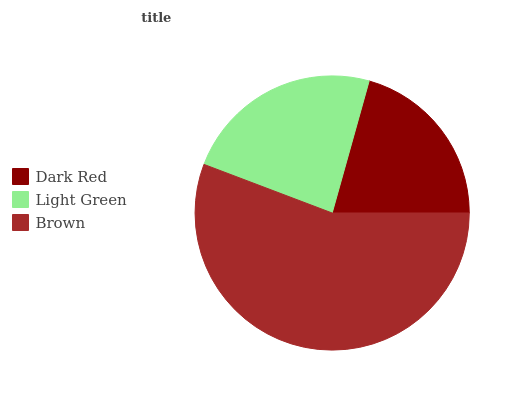Is Dark Red the minimum?
Answer yes or no. Yes. Is Brown the maximum?
Answer yes or no. Yes. Is Light Green the minimum?
Answer yes or no. No. Is Light Green the maximum?
Answer yes or no. No. Is Light Green greater than Dark Red?
Answer yes or no. Yes. Is Dark Red less than Light Green?
Answer yes or no. Yes. Is Dark Red greater than Light Green?
Answer yes or no. No. Is Light Green less than Dark Red?
Answer yes or no. No. Is Light Green the high median?
Answer yes or no. Yes. Is Light Green the low median?
Answer yes or no. Yes. Is Brown the high median?
Answer yes or no. No. Is Brown the low median?
Answer yes or no. No. 